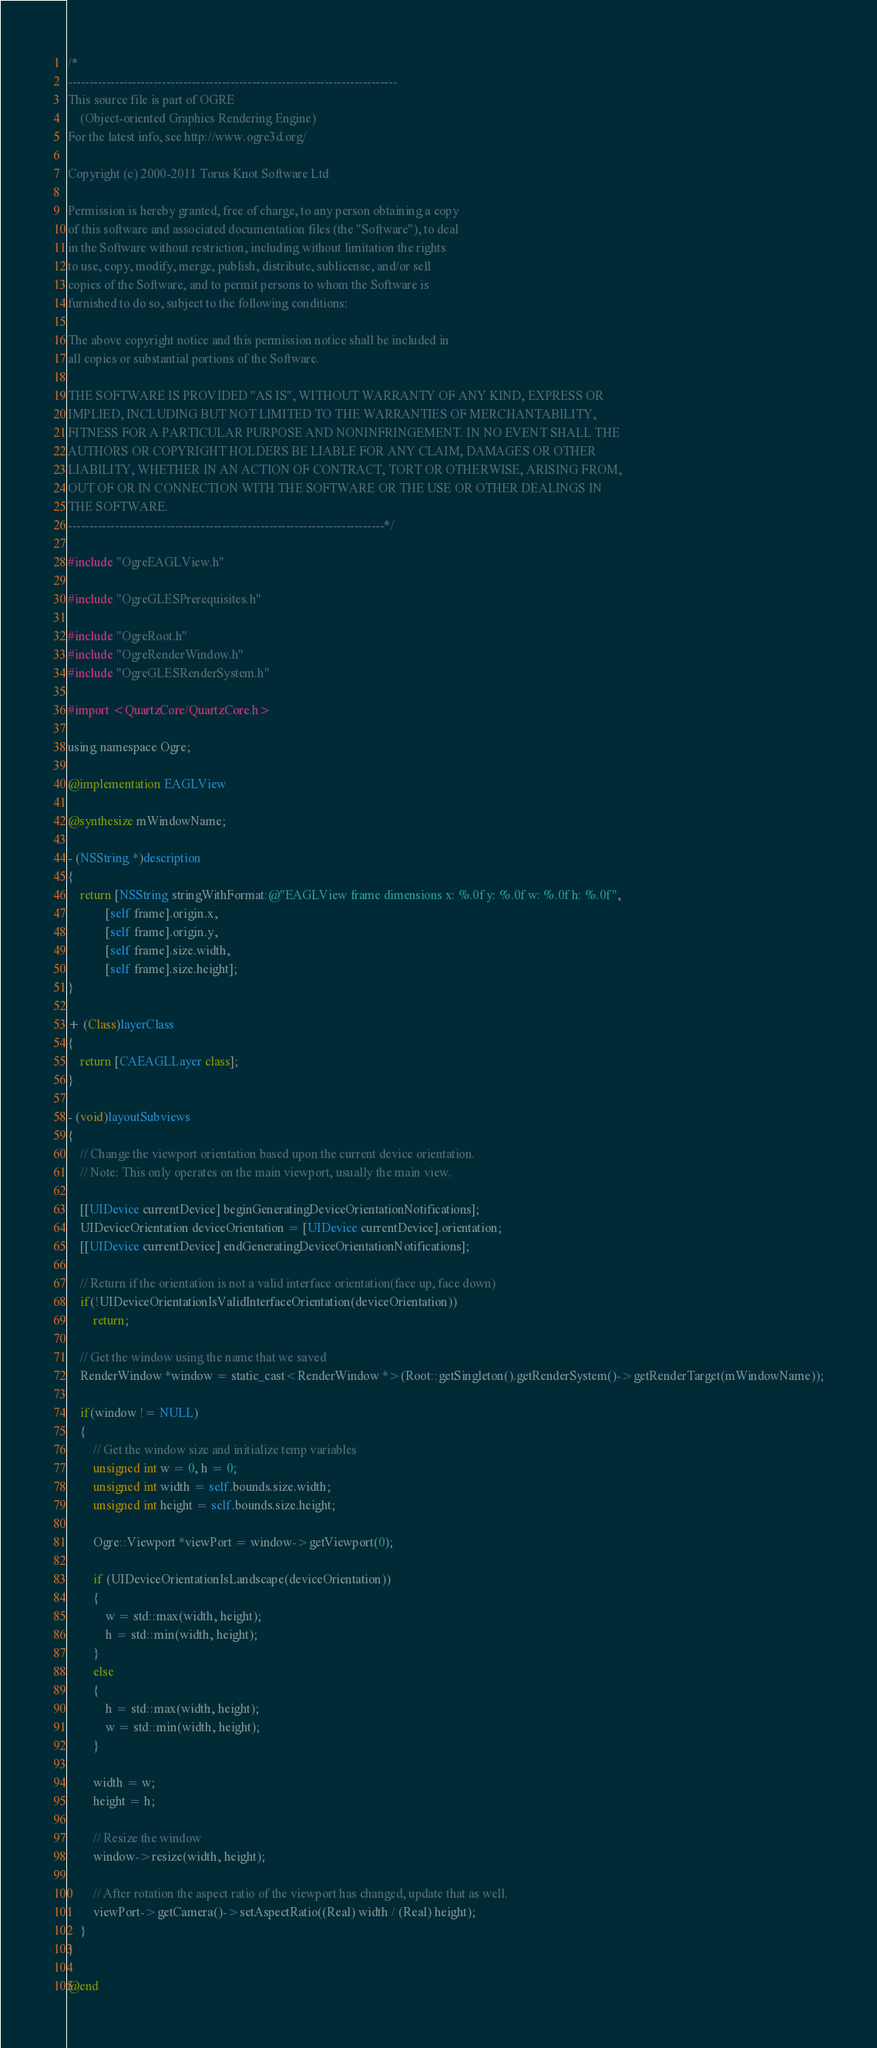<code> <loc_0><loc_0><loc_500><loc_500><_ObjectiveC_>/*
-----------------------------------------------------------------------------
This source file is part of OGRE
    (Object-oriented Graphics Rendering Engine)
For the latest info, see http://www.ogre3d.org/

Copyright (c) 2000-2011 Torus Knot Software Ltd

Permission is hereby granted, free of charge, to any person obtaining a copy
of this software and associated documentation files (the "Software"), to deal
in the Software without restriction, including without limitation the rights
to use, copy, modify, merge, publish, distribute, sublicense, and/or sell
copies of the Software, and to permit persons to whom the Software is
furnished to do so, subject to the following conditions:

The above copyright notice and this permission notice shall be included in
all copies or substantial portions of the Software.

THE SOFTWARE IS PROVIDED "AS IS", WITHOUT WARRANTY OF ANY KIND, EXPRESS OR
IMPLIED, INCLUDING BUT NOT LIMITED TO THE WARRANTIES OF MERCHANTABILITY,
FITNESS FOR A PARTICULAR PURPOSE AND NONINFRINGEMENT. IN NO EVENT SHALL THE
AUTHORS OR COPYRIGHT HOLDERS BE LIABLE FOR ANY CLAIM, DAMAGES OR OTHER
LIABILITY, WHETHER IN AN ACTION OF CONTRACT, TORT OR OTHERWISE, ARISING FROM,
OUT OF OR IN CONNECTION WITH THE SOFTWARE OR THE USE OR OTHER DEALINGS IN
THE SOFTWARE.
--------------------------------------------------------------------------*/

#include "OgreEAGLView.h"

#include "OgreGLESPrerequisites.h"

#include "OgreRoot.h"
#include "OgreRenderWindow.h"
#include "OgreGLESRenderSystem.h"

#import <QuartzCore/QuartzCore.h>

using namespace Ogre;

@implementation EAGLView

@synthesize mWindowName;

- (NSString *)description
{
    return [NSString stringWithFormat:@"EAGLView frame dimensions x: %.0f y: %.0f w: %.0f h: %.0f", 
            [self frame].origin.x,
            [self frame].origin.y,
            [self frame].size.width,
            [self frame].size.height];
}

+ (Class)layerClass
{
    return [CAEAGLLayer class];
}

- (void)layoutSubviews
{
    // Change the viewport orientation based upon the current device orientation.
    // Note: This only operates on the main viewport, usually the main view.

    [[UIDevice currentDevice] beginGeneratingDeviceOrientationNotifications];
    UIDeviceOrientation deviceOrientation = [UIDevice currentDevice].orientation;
    [[UIDevice currentDevice] endGeneratingDeviceOrientationNotifications];

    // Return if the orientation is not a valid interface orientation(face up, face down)
    if(!UIDeviceOrientationIsValidInterfaceOrientation(deviceOrientation))
        return;

    // Get the window using the name that we saved
    RenderWindow *window = static_cast<RenderWindow *>(Root::getSingleton().getRenderSystem()->getRenderTarget(mWindowName));

    if(window != NULL)
    {
        // Get the window size and initialize temp variables
        unsigned int w = 0, h = 0;
        unsigned int width = self.bounds.size.width;
        unsigned int height = self.bounds.size.height;

        Ogre::Viewport *viewPort = window->getViewport(0);

        if (UIDeviceOrientationIsLandscape(deviceOrientation))
        {
            w = std::max(width, height);
            h = std::min(width, height);
        }
        else
        {
            h = std::max(width, height);
            w = std::min(width, height);
        }

        width = w;
        height = h;

        // Resize the window
        window->resize(width, height);

        // After rotation the aspect ratio of the viewport has changed, update that as well.
        viewPort->getCamera()->setAspectRatio((Real) width / (Real) height);
    }
}

@end
</code> 